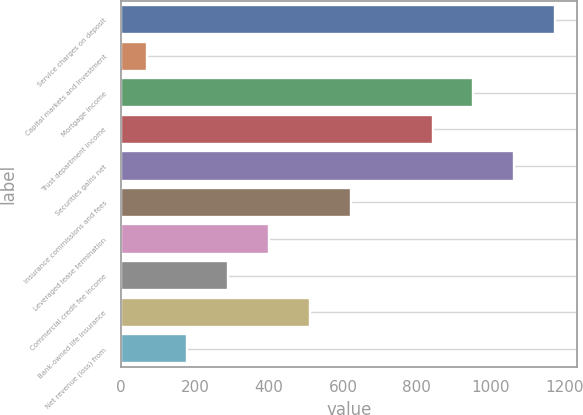Convert chart. <chart><loc_0><loc_0><loc_500><loc_500><bar_chart><fcel>Service charges on deposit<fcel>Capital markets and investment<fcel>Mortgage income<fcel>Trust department income<fcel>Securities gains net<fcel>Insurance commissions and fees<fcel>Leveraged lease termination<fcel>Commercial credit fee income<fcel>Bank-owned life insurance<fcel>Net revenue (loss) from<nl><fcel>1174<fcel>69<fcel>953<fcel>842.5<fcel>1063.5<fcel>621.5<fcel>400.5<fcel>290<fcel>511<fcel>179.5<nl></chart> 